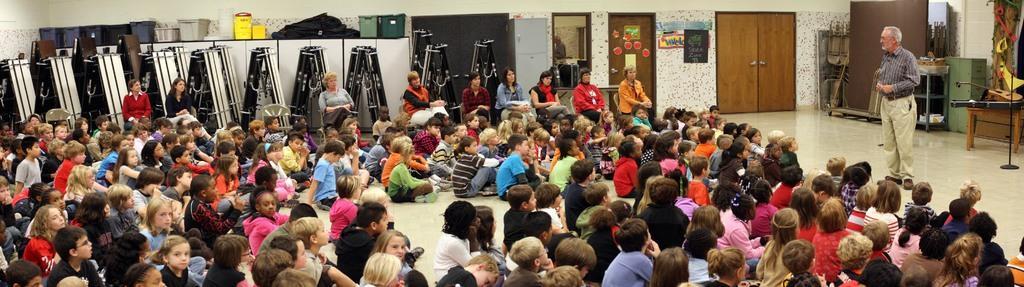Can you describe this image briefly? There are groups of children sitting on the floor and few women sitting on the chairs. Here is the man standing. These are the doors. I can see a mirror, which is attached to the wall. These are the wardrobes and ladders. I can see the baskets and few other things placed above the wardrobe. I can see few objects here. This looks like a guitar, which is placed on the table. 